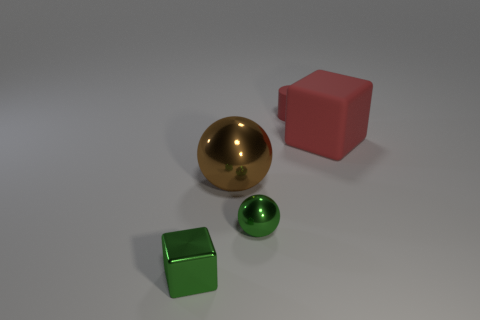What is the shape of the tiny thing that is the same color as the metallic block?
Provide a short and direct response. Sphere. There is another green object that is the same shape as the big metallic thing; what is its size?
Give a very brief answer. Small. There is a big brown thing that is right of the small cube; what is its shape?
Give a very brief answer. Sphere. Is there any other thing that is the same shape as the brown thing?
Offer a terse response. Yes. Is there a big cyan shiny sphere?
Provide a short and direct response. No. There is a cube on the right side of the large ball; does it have the same size as the metallic ball that is to the left of the small green metallic ball?
Make the answer very short. Yes. What is the material of the thing that is in front of the large rubber object and on the right side of the brown metallic sphere?
Provide a succinct answer. Metal. There is a small cube; how many tiny rubber cylinders are in front of it?
Ensure brevity in your answer.  0. There is a small thing that is made of the same material as the small green block; what is its color?
Give a very brief answer. Green. What number of objects are to the right of the tiny rubber thing and to the left of the brown metal sphere?
Ensure brevity in your answer.  0. 